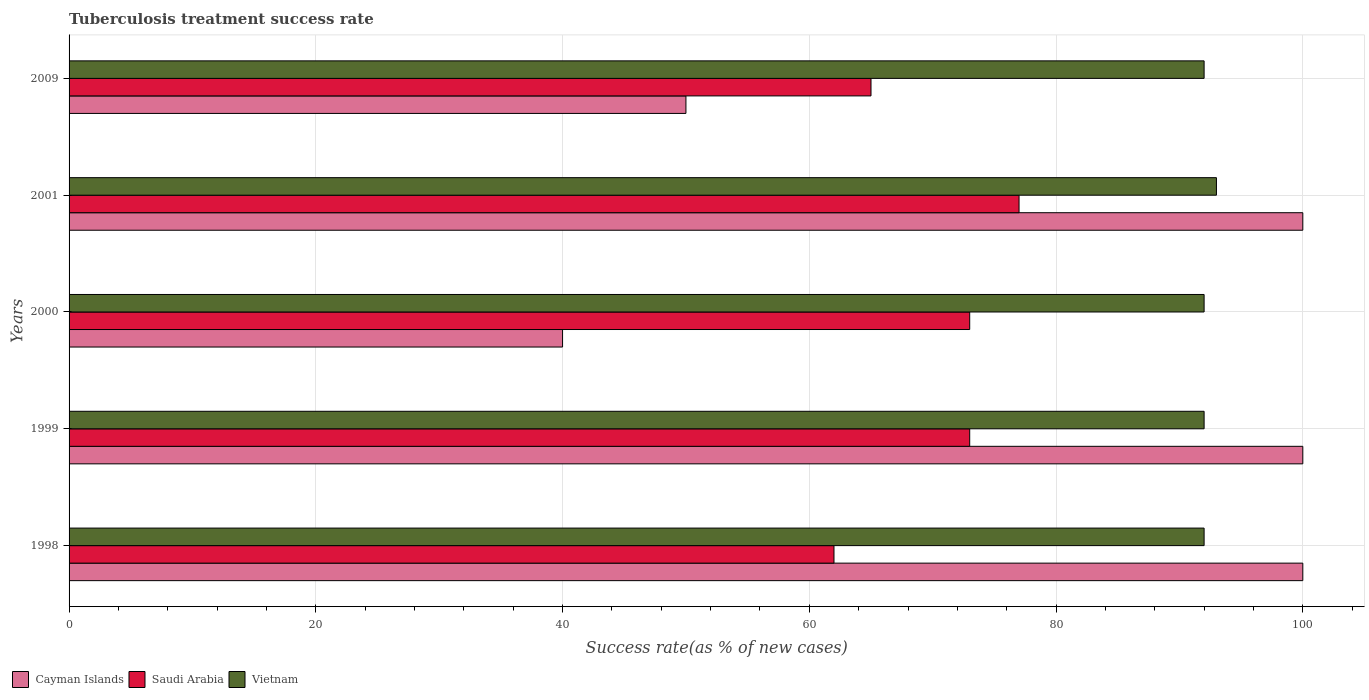How many groups of bars are there?
Your answer should be compact. 5. Are the number of bars per tick equal to the number of legend labels?
Your answer should be compact. Yes. How many bars are there on the 4th tick from the top?
Offer a terse response. 3. What is the label of the 2nd group of bars from the top?
Your answer should be compact. 2001. What is the tuberculosis treatment success rate in Saudi Arabia in 2001?
Your response must be concise. 77. Across all years, what is the maximum tuberculosis treatment success rate in Cayman Islands?
Make the answer very short. 100. Across all years, what is the minimum tuberculosis treatment success rate in Cayman Islands?
Your answer should be compact. 40. In which year was the tuberculosis treatment success rate in Vietnam maximum?
Make the answer very short. 2001. What is the total tuberculosis treatment success rate in Saudi Arabia in the graph?
Make the answer very short. 350. What is the average tuberculosis treatment success rate in Cayman Islands per year?
Your response must be concise. 78. In the year 2000, what is the difference between the tuberculosis treatment success rate in Saudi Arabia and tuberculosis treatment success rate in Cayman Islands?
Give a very brief answer. 33. Is the tuberculosis treatment success rate in Saudi Arabia in 2000 less than that in 2001?
Provide a short and direct response. Yes. Is the sum of the tuberculosis treatment success rate in Saudi Arabia in 1998 and 2001 greater than the maximum tuberculosis treatment success rate in Cayman Islands across all years?
Your answer should be compact. Yes. What does the 3rd bar from the top in 2000 represents?
Give a very brief answer. Cayman Islands. What does the 3rd bar from the bottom in 2000 represents?
Keep it short and to the point. Vietnam. How many bars are there?
Give a very brief answer. 15. What is the difference between two consecutive major ticks on the X-axis?
Make the answer very short. 20. Does the graph contain any zero values?
Give a very brief answer. No. How are the legend labels stacked?
Your response must be concise. Horizontal. What is the title of the graph?
Your answer should be compact. Tuberculosis treatment success rate. Does "Azerbaijan" appear as one of the legend labels in the graph?
Offer a very short reply. No. What is the label or title of the X-axis?
Provide a succinct answer. Success rate(as % of new cases). What is the label or title of the Y-axis?
Provide a short and direct response. Years. What is the Success rate(as % of new cases) of Vietnam in 1998?
Your response must be concise. 92. What is the Success rate(as % of new cases) in Saudi Arabia in 1999?
Make the answer very short. 73. What is the Success rate(as % of new cases) of Vietnam in 1999?
Provide a succinct answer. 92. What is the Success rate(as % of new cases) of Vietnam in 2000?
Give a very brief answer. 92. What is the Success rate(as % of new cases) in Cayman Islands in 2001?
Provide a succinct answer. 100. What is the Success rate(as % of new cases) in Saudi Arabia in 2001?
Your answer should be compact. 77. What is the Success rate(as % of new cases) in Vietnam in 2001?
Offer a terse response. 93. What is the Success rate(as % of new cases) in Cayman Islands in 2009?
Provide a short and direct response. 50. What is the Success rate(as % of new cases) in Saudi Arabia in 2009?
Offer a terse response. 65. What is the Success rate(as % of new cases) in Vietnam in 2009?
Your response must be concise. 92. Across all years, what is the maximum Success rate(as % of new cases) in Saudi Arabia?
Provide a short and direct response. 77. Across all years, what is the maximum Success rate(as % of new cases) in Vietnam?
Provide a short and direct response. 93. Across all years, what is the minimum Success rate(as % of new cases) of Saudi Arabia?
Offer a very short reply. 62. Across all years, what is the minimum Success rate(as % of new cases) of Vietnam?
Give a very brief answer. 92. What is the total Success rate(as % of new cases) of Cayman Islands in the graph?
Provide a succinct answer. 390. What is the total Success rate(as % of new cases) of Saudi Arabia in the graph?
Ensure brevity in your answer.  350. What is the total Success rate(as % of new cases) in Vietnam in the graph?
Make the answer very short. 461. What is the difference between the Success rate(as % of new cases) of Cayman Islands in 1998 and that in 1999?
Your answer should be compact. 0. What is the difference between the Success rate(as % of new cases) of Vietnam in 1998 and that in 1999?
Give a very brief answer. 0. What is the difference between the Success rate(as % of new cases) of Saudi Arabia in 1998 and that in 2000?
Your response must be concise. -11. What is the difference between the Success rate(as % of new cases) of Vietnam in 1998 and that in 2000?
Your answer should be very brief. 0. What is the difference between the Success rate(as % of new cases) in Saudi Arabia in 1998 and that in 2001?
Offer a very short reply. -15. What is the difference between the Success rate(as % of new cases) of Cayman Islands in 1998 and that in 2009?
Give a very brief answer. 50. What is the difference between the Success rate(as % of new cases) of Cayman Islands in 1999 and that in 2001?
Provide a succinct answer. 0. What is the difference between the Success rate(as % of new cases) in Saudi Arabia in 1999 and that in 2001?
Your answer should be very brief. -4. What is the difference between the Success rate(as % of new cases) of Vietnam in 1999 and that in 2001?
Ensure brevity in your answer.  -1. What is the difference between the Success rate(as % of new cases) in Cayman Islands in 1999 and that in 2009?
Offer a terse response. 50. What is the difference between the Success rate(as % of new cases) in Saudi Arabia in 1999 and that in 2009?
Ensure brevity in your answer.  8. What is the difference between the Success rate(as % of new cases) in Cayman Islands in 2000 and that in 2001?
Provide a succinct answer. -60. What is the difference between the Success rate(as % of new cases) of Vietnam in 2000 and that in 2001?
Keep it short and to the point. -1. What is the difference between the Success rate(as % of new cases) of Saudi Arabia in 2000 and that in 2009?
Your answer should be very brief. 8. What is the difference between the Success rate(as % of new cases) of Cayman Islands in 2001 and that in 2009?
Provide a short and direct response. 50. What is the difference between the Success rate(as % of new cases) of Saudi Arabia in 2001 and that in 2009?
Provide a short and direct response. 12. What is the difference between the Success rate(as % of new cases) in Vietnam in 2001 and that in 2009?
Make the answer very short. 1. What is the difference between the Success rate(as % of new cases) in Cayman Islands in 1998 and the Success rate(as % of new cases) in Vietnam in 1999?
Ensure brevity in your answer.  8. What is the difference between the Success rate(as % of new cases) of Cayman Islands in 1998 and the Success rate(as % of new cases) of Vietnam in 2001?
Keep it short and to the point. 7. What is the difference between the Success rate(as % of new cases) of Saudi Arabia in 1998 and the Success rate(as % of new cases) of Vietnam in 2001?
Your answer should be very brief. -31. What is the difference between the Success rate(as % of new cases) in Cayman Islands in 1998 and the Success rate(as % of new cases) in Vietnam in 2009?
Ensure brevity in your answer.  8. What is the difference between the Success rate(as % of new cases) of Saudi Arabia in 1998 and the Success rate(as % of new cases) of Vietnam in 2009?
Offer a terse response. -30. What is the difference between the Success rate(as % of new cases) of Saudi Arabia in 1999 and the Success rate(as % of new cases) of Vietnam in 2000?
Provide a short and direct response. -19. What is the difference between the Success rate(as % of new cases) of Cayman Islands in 1999 and the Success rate(as % of new cases) of Saudi Arabia in 2001?
Offer a very short reply. 23. What is the difference between the Success rate(as % of new cases) of Cayman Islands in 1999 and the Success rate(as % of new cases) of Vietnam in 2001?
Your response must be concise. 7. What is the difference between the Success rate(as % of new cases) of Cayman Islands in 1999 and the Success rate(as % of new cases) of Saudi Arabia in 2009?
Offer a terse response. 35. What is the difference between the Success rate(as % of new cases) in Cayman Islands in 2000 and the Success rate(as % of new cases) in Saudi Arabia in 2001?
Offer a terse response. -37. What is the difference between the Success rate(as % of new cases) in Cayman Islands in 2000 and the Success rate(as % of new cases) in Vietnam in 2001?
Offer a terse response. -53. What is the difference between the Success rate(as % of new cases) in Saudi Arabia in 2000 and the Success rate(as % of new cases) in Vietnam in 2001?
Ensure brevity in your answer.  -20. What is the difference between the Success rate(as % of new cases) of Cayman Islands in 2000 and the Success rate(as % of new cases) of Saudi Arabia in 2009?
Offer a terse response. -25. What is the difference between the Success rate(as % of new cases) of Cayman Islands in 2000 and the Success rate(as % of new cases) of Vietnam in 2009?
Your answer should be compact. -52. What is the difference between the Success rate(as % of new cases) of Cayman Islands in 2001 and the Success rate(as % of new cases) of Vietnam in 2009?
Your response must be concise. 8. What is the average Success rate(as % of new cases) of Vietnam per year?
Your answer should be very brief. 92.2. In the year 1998, what is the difference between the Success rate(as % of new cases) in Cayman Islands and Success rate(as % of new cases) in Saudi Arabia?
Your answer should be very brief. 38. In the year 1998, what is the difference between the Success rate(as % of new cases) of Cayman Islands and Success rate(as % of new cases) of Vietnam?
Ensure brevity in your answer.  8. In the year 1999, what is the difference between the Success rate(as % of new cases) of Saudi Arabia and Success rate(as % of new cases) of Vietnam?
Your answer should be compact. -19. In the year 2000, what is the difference between the Success rate(as % of new cases) in Cayman Islands and Success rate(as % of new cases) in Saudi Arabia?
Provide a short and direct response. -33. In the year 2000, what is the difference between the Success rate(as % of new cases) in Cayman Islands and Success rate(as % of new cases) in Vietnam?
Your answer should be compact. -52. In the year 2000, what is the difference between the Success rate(as % of new cases) of Saudi Arabia and Success rate(as % of new cases) of Vietnam?
Your response must be concise. -19. In the year 2001, what is the difference between the Success rate(as % of new cases) in Cayman Islands and Success rate(as % of new cases) in Saudi Arabia?
Make the answer very short. 23. In the year 2009, what is the difference between the Success rate(as % of new cases) in Cayman Islands and Success rate(as % of new cases) in Saudi Arabia?
Offer a terse response. -15. In the year 2009, what is the difference between the Success rate(as % of new cases) of Cayman Islands and Success rate(as % of new cases) of Vietnam?
Your answer should be compact. -42. In the year 2009, what is the difference between the Success rate(as % of new cases) of Saudi Arabia and Success rate(as % of new cases) of Vietnam?
Keep it short and to the point. -27. What is the ratio of the Success rate(as % of new cases) in Cayman Islands in 1998 to that in 1999?
Your answer should be compact. 1. What is the ratio of the Success rate(as % of new cases) in Saudi Arabia in 1998 to that in 1999?
Give a very brief answer. 0.85. What is the ratio of the Success rate(as % of new cases) of Vietnam in 1998 to that in 1999?
Make the answer very short. 1. What is the ratio of the Success rate(as % of new cases) in Cayman Islands in 1998 to that in 2000?
Offer a very short reply. 2.5. What is the ratio of the Success rate(as % of new cases) of Saudi Arabia in 1998 to that in 2000?
Ensure brevity in your answer.  0.85. What is the ratio of the Success rate(as % of new cases) in Cayman Islands in 1998 to that in 2001?
Your answer should be very brief. 1. What is the ratio of the Success rate(as % of new cases) of Saudi Arabia in 1998 to that in 2001?
Provide a short and direct response. 0.81. What is the ratio of the Success rate(as % of new cases) of Vietnam in 1998 to that in 2001?
Your response must be concise. 0.99. What is the ratio of the Success rate(as % of new cases) of Saudi Arabia in 1998 to that in 2009?
Provide a short and direct response. 0.95. What is the ratio of the Success rate(as % of new cases) in Vietnam in 1998 to that in 2009?
Offer a very short reply. 1. What is the ratio of the Success rate(as % of new cases) in Saudi Arabia in 1999 to that in 2000?
Provide a succinct answer. 1. What is the ratio of the Success rate(as % of new cases) of Cayman Islands in 1999 to that in 2001?
Offer a terse response. 1. What is the ratio of the Success rate(as % of new cases) in Saudi Arabia in 1999 to that in 2001?
Give a very brief answer. 0.95. What is the ratio of the Success rate(as % of new cases) in Saudi Arabia in 1999 to that in 2009?
Your answer should be very brief. 1.12. What is the ratio of the Success rate(as % of new cases) of Vietnam in 1999 to that in 2009?
Offer a very short reply. 1. What is the ratio of the Success rate(as % of new cases) of Saudi Arabia in 2000 to that in 2001?
Keep it short and to the point. 0.95. What is the ratio of the Success rate(as % of new cases) in Vietnam in 2000 to that in 2001?
Your response must be concise. 0.99. What is the ratio of the Success rate(as % of new cases) in Cayman Islands in 2000 to that in 2009?
Provide a succinct answer. 0.8. What is the ratio of the Success rate(as % of new cases) of Saudi Arabia in 2000 to that in 2009?
Your answer should be compact. 1.12. What is the ratio of the Success rate(as % of new cases) in Saudi Arabia in 2001 to that in 2009?
Your answer should be compact. 1.18. What is the ratio of the Success rate(as % of new cases) in Vietnam in 2001 to that in 2009?
Provide a succinct answer. 1.01. What is the difference between the highest and the second highest Success rate(as % of new cases) of Saudi Arabia?
Provide a succinct answer. 4. What is the difference between the highest and the lowest Success rate(as % of new cases) in Cayman Islands?
Make the answer very short. 60. 